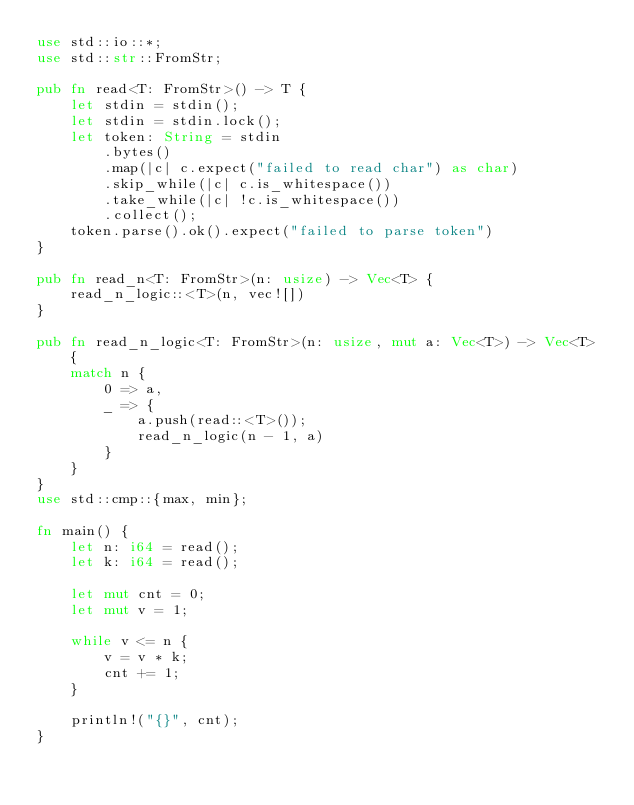<code> <loc_0><loc_0><loc_500><loc_500><_Rust_>use std::io::*;
use std::str::FromStr;

pub fn read<T: FromStr>() -> T {
    let stdin = stdin();
    let stdin = stdin.lock();
    let token: String = stdin
        .bytes()
        .map(|c| c.expect("failed to read char") as char)
        .skip_while(|c| c.is_whitespace())
        .take_while(|c| !c.is_whitespace())
        .collect();
    token.parse().ok().expect("failed to parse token")
}

pub fn read_n<T: FromStr>(n: usize) -> Vec<T> {
    read_n_logic::<T>(n, vec![])
}

pub fn read_n_logic<T: FromStr>(n: usize, mut a: Vec<T>) -> Vec<T> {
    match n {
        0 => a,
        _ => {
            a.push(read::<T>());
            read_n_logic(n - 1, a)
        }
    }
}
use std::cmp::{max, min};

fn main() {
    let n: i64 = read();
    let k: i64 = read();

    let mut cnt = 0;
    let mut v = 1;

    while v <= n {
        v = v * k;
        cnt += 1;
    }

    println!("{}", cnt);
}
</code> 